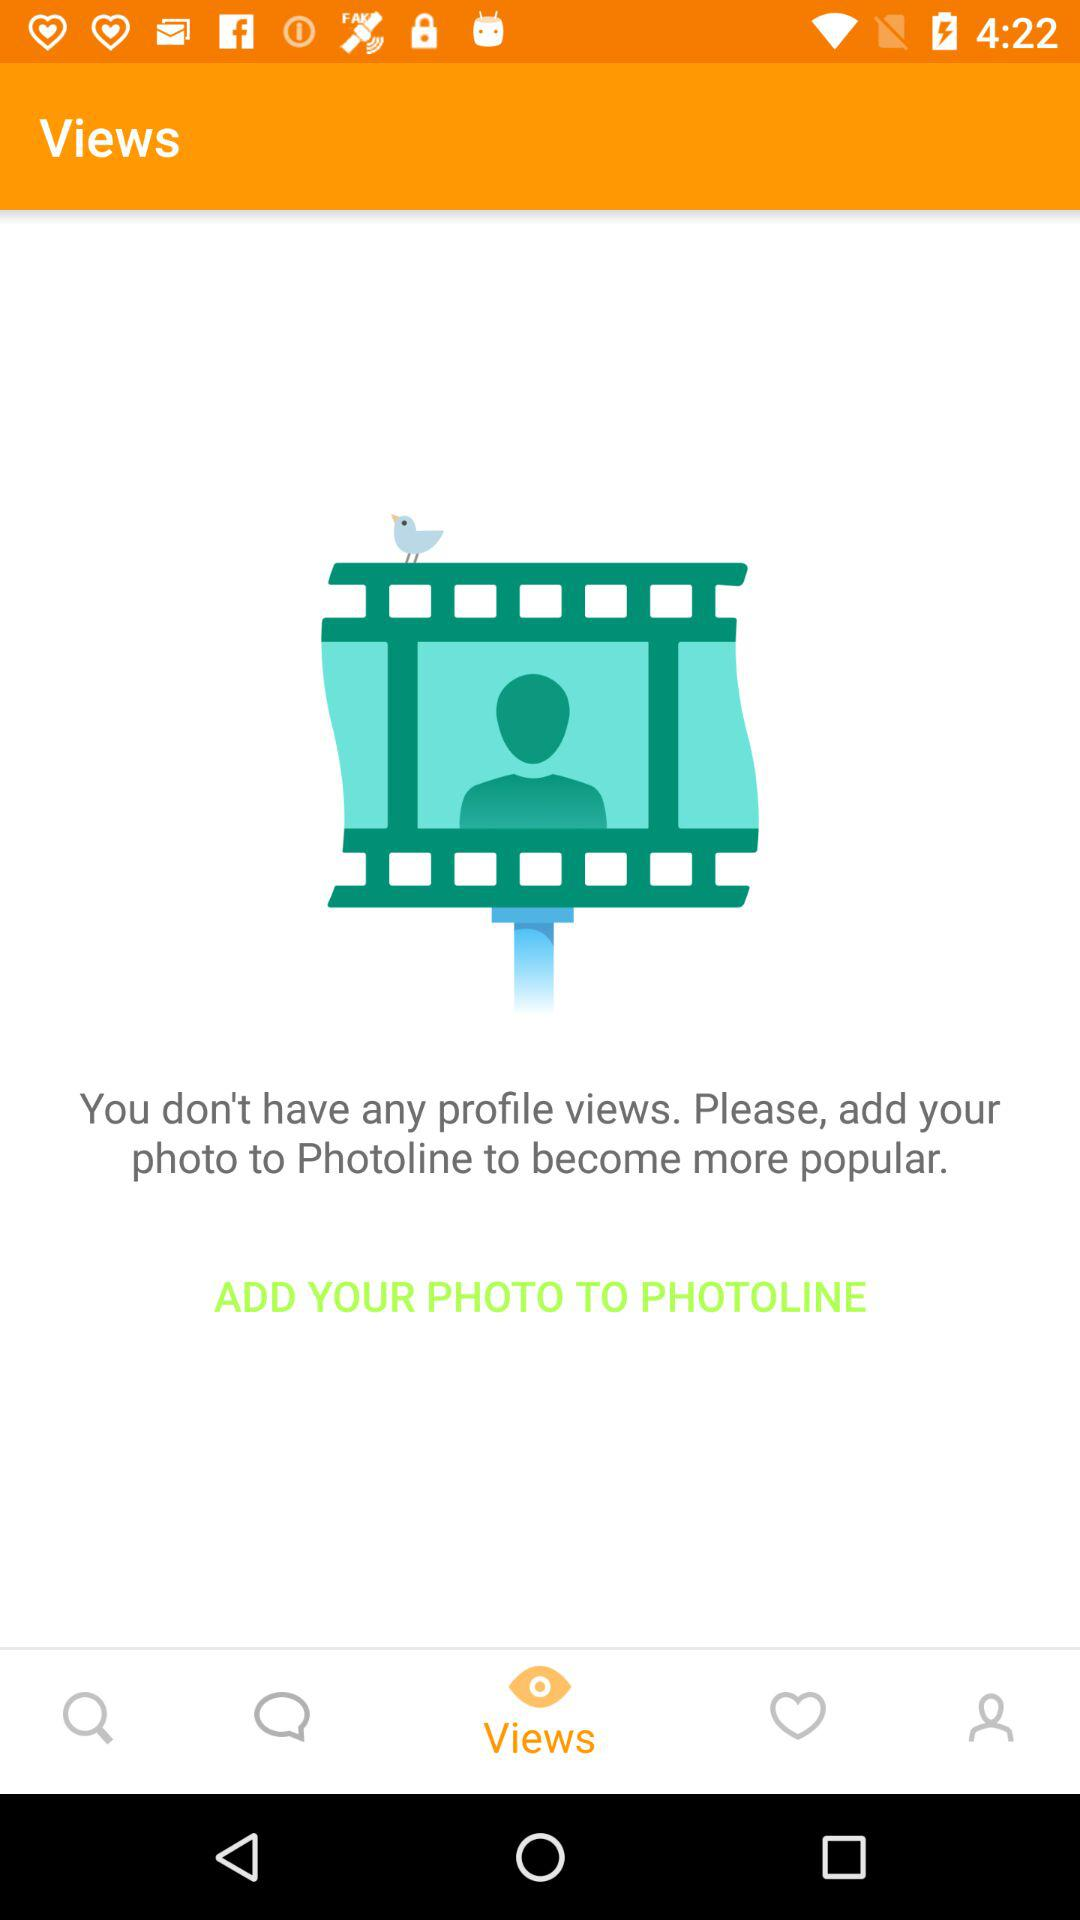How many views does the user have?
Answer the question using a single word or phrase. 0 